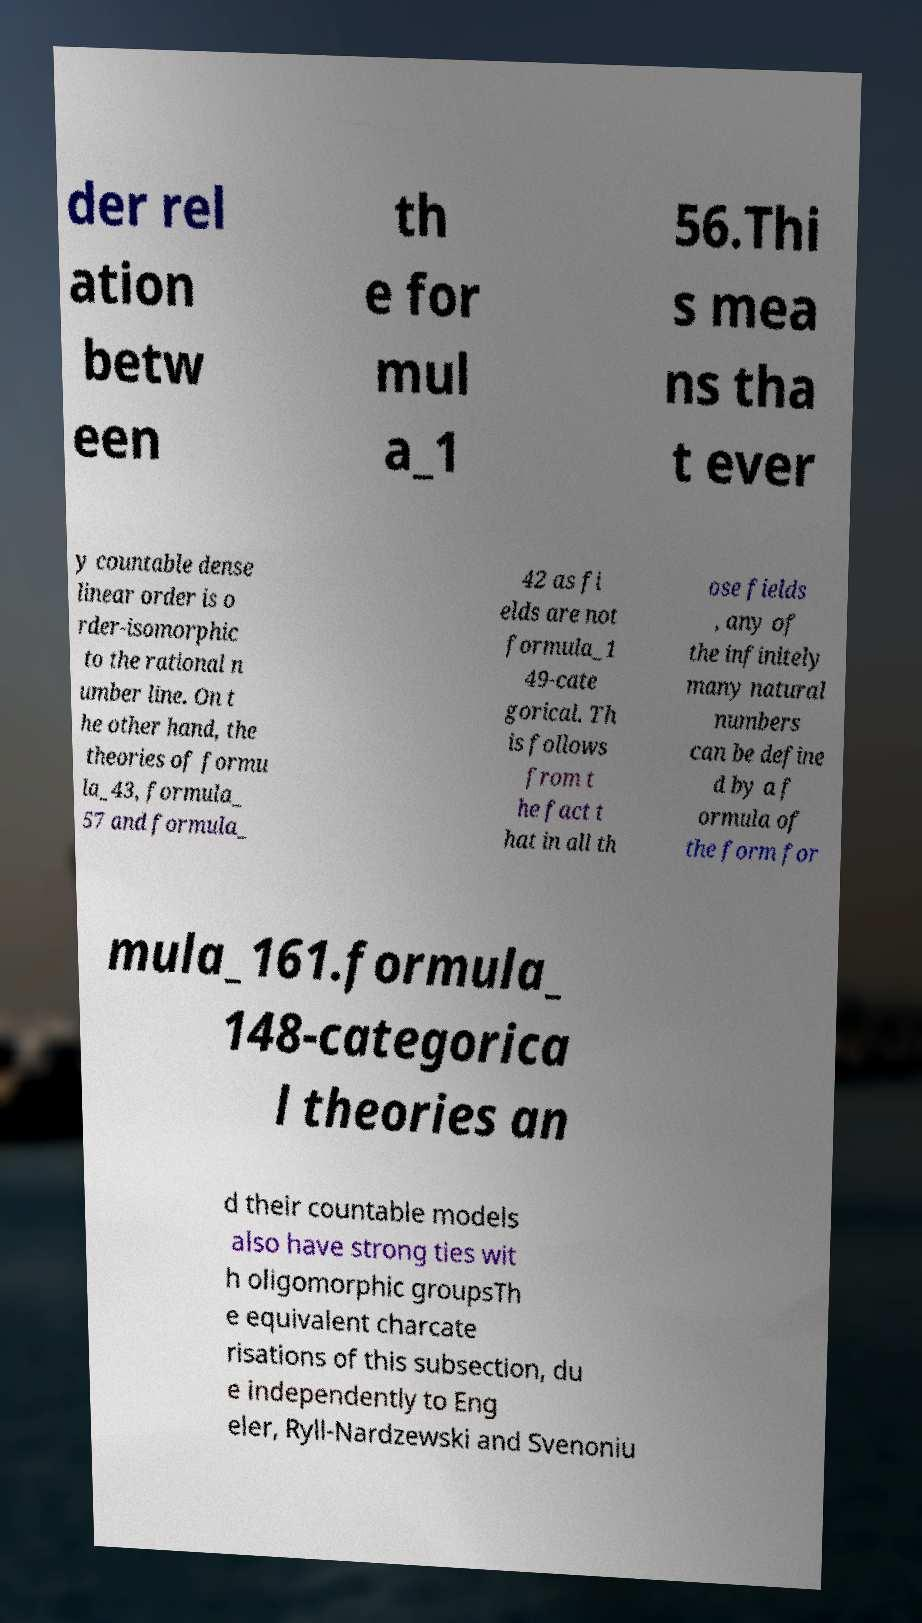Could you assist in decoding the text presented in this image and type it out clearly? der rel ation betw een th e for mul a_1 56.Thi s mea ns tha t ever y countable dense linear order is o rder-isomorphic to the rational n umber line. On t he other hand, the theories of formu la_43, formula_ 57 and formula_ 42 as fi elds are not formula_1 49-cate gorical. Th is follows from t he fact t hat in all th ose fields , any of the infinitely many natural numbers can be define d by a f ormula of the form for mula_161.formula_ 148-categorica l theories an d their countable models also have strong ties wit h oligomorphic groupsTh e equivalent charcate risations of this subsection, du e independently to Eng eler, Ryll-Nardzewski and Svenoniu 